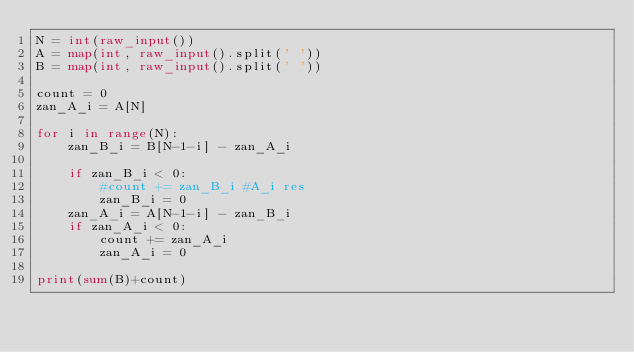<code> <loc_0><loc_0><loc_500><loc_500><_Python_>N = int(raw_input())
A = map(int, raw_input().split(' '))
B = map(int, raw_input().split(' '))

count = 0
zan_A_i = A[N]

for i in range(N):
    zan_B_i = B[N-1-i] - zan_A_i

    if zan_B_i < 0:
        #count += zan_B_i #A_i res
        zan_B_i = 0
    zan_A_i = A[N-1-i] - zan_B_i
    if zan_A_i < 0:
        count += zan_A_i 
        zan_A_i = 0

print(sum(B)+count)
</code> 